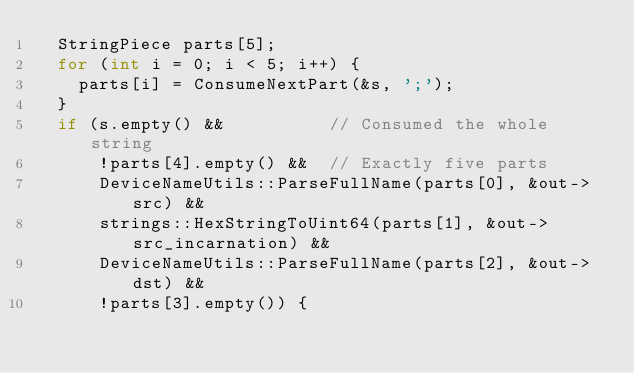Convert code to text. <code><loc_0><loc_0><loc_500><loc_500><_C++_>  StringPiece parts[5];
  for (int i = 0; i < 5; i++) {
    parts[i] = ConsumeNextPart(&s, ';');
  }
  if (s.empty() &&          // Consumed the whole string
      !parts[4].empty() &&  // Exactly five parts
      DeviceNameUtils::ParseFullName(parts[0], &out->src) &&
      strings::HexStringToUint64(parts[1], &out->src_incarnation) &&
      DeviceNameUtils::ParseFullName(parts[2], &out->dst) &&
      !parts[3].empty()) {</code> 